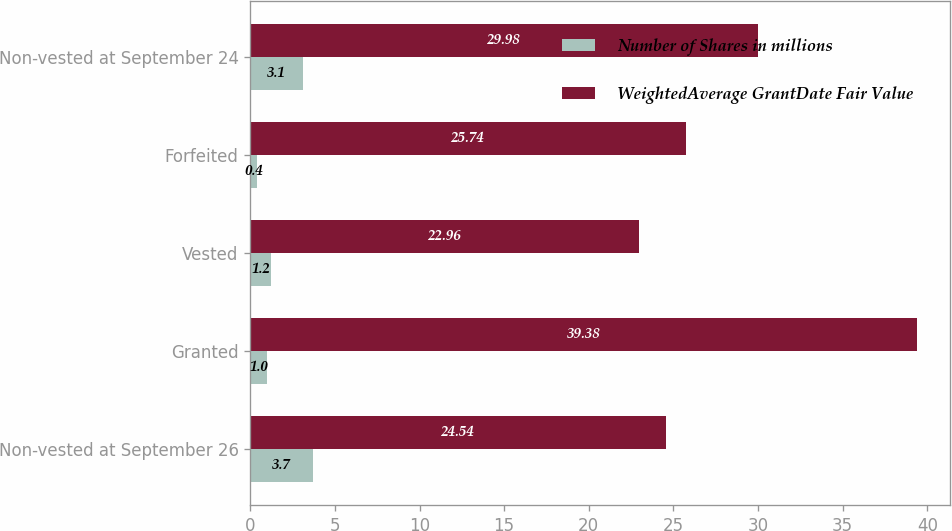Convert chart to OTSL. <chart><loc_0><loc_0><loc_500><loc_500><stacked_bar_chart><ecel><fcel>Non-vested at September 26<fcel>Granted<fcel>Vested<fcel>Forfeited<fcel>Non-vested at September 24<nl><fcel>Number of Shares in millions<fcel>3.7<fcel>1<fcel>1.2<fcel>0.4<fcel>3.1<nl><fcel>WeightedAverage GrantDate Fair Value<fcel>24.54<fcel>39.38<fcel>22.96<fcel>25.74<fcel>29.98<nl></chart> 